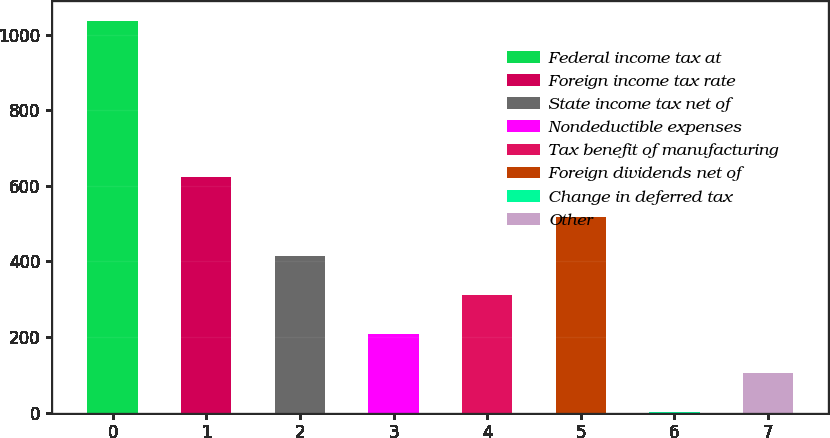Convert chart. <chart><loc_0><loc_0><loc_500><loc_500><bar_chart><fcel>Federal income tax at<fcel>Foreign income tax rate<fcel>State income tax net of<fcel>Nondeductible expenses<fcel>Tax benefit of manufacturing<fcel>Foreign dividends net of<fcel>Change in deferred tax<fcel>Other<nl><fcel>1036.5<fcel>622.06<fcel>414.84<fcel>207.62<fcel>311.23<fcel>518.45<fcel>0.4<fcel>104.01<nl></chart> 